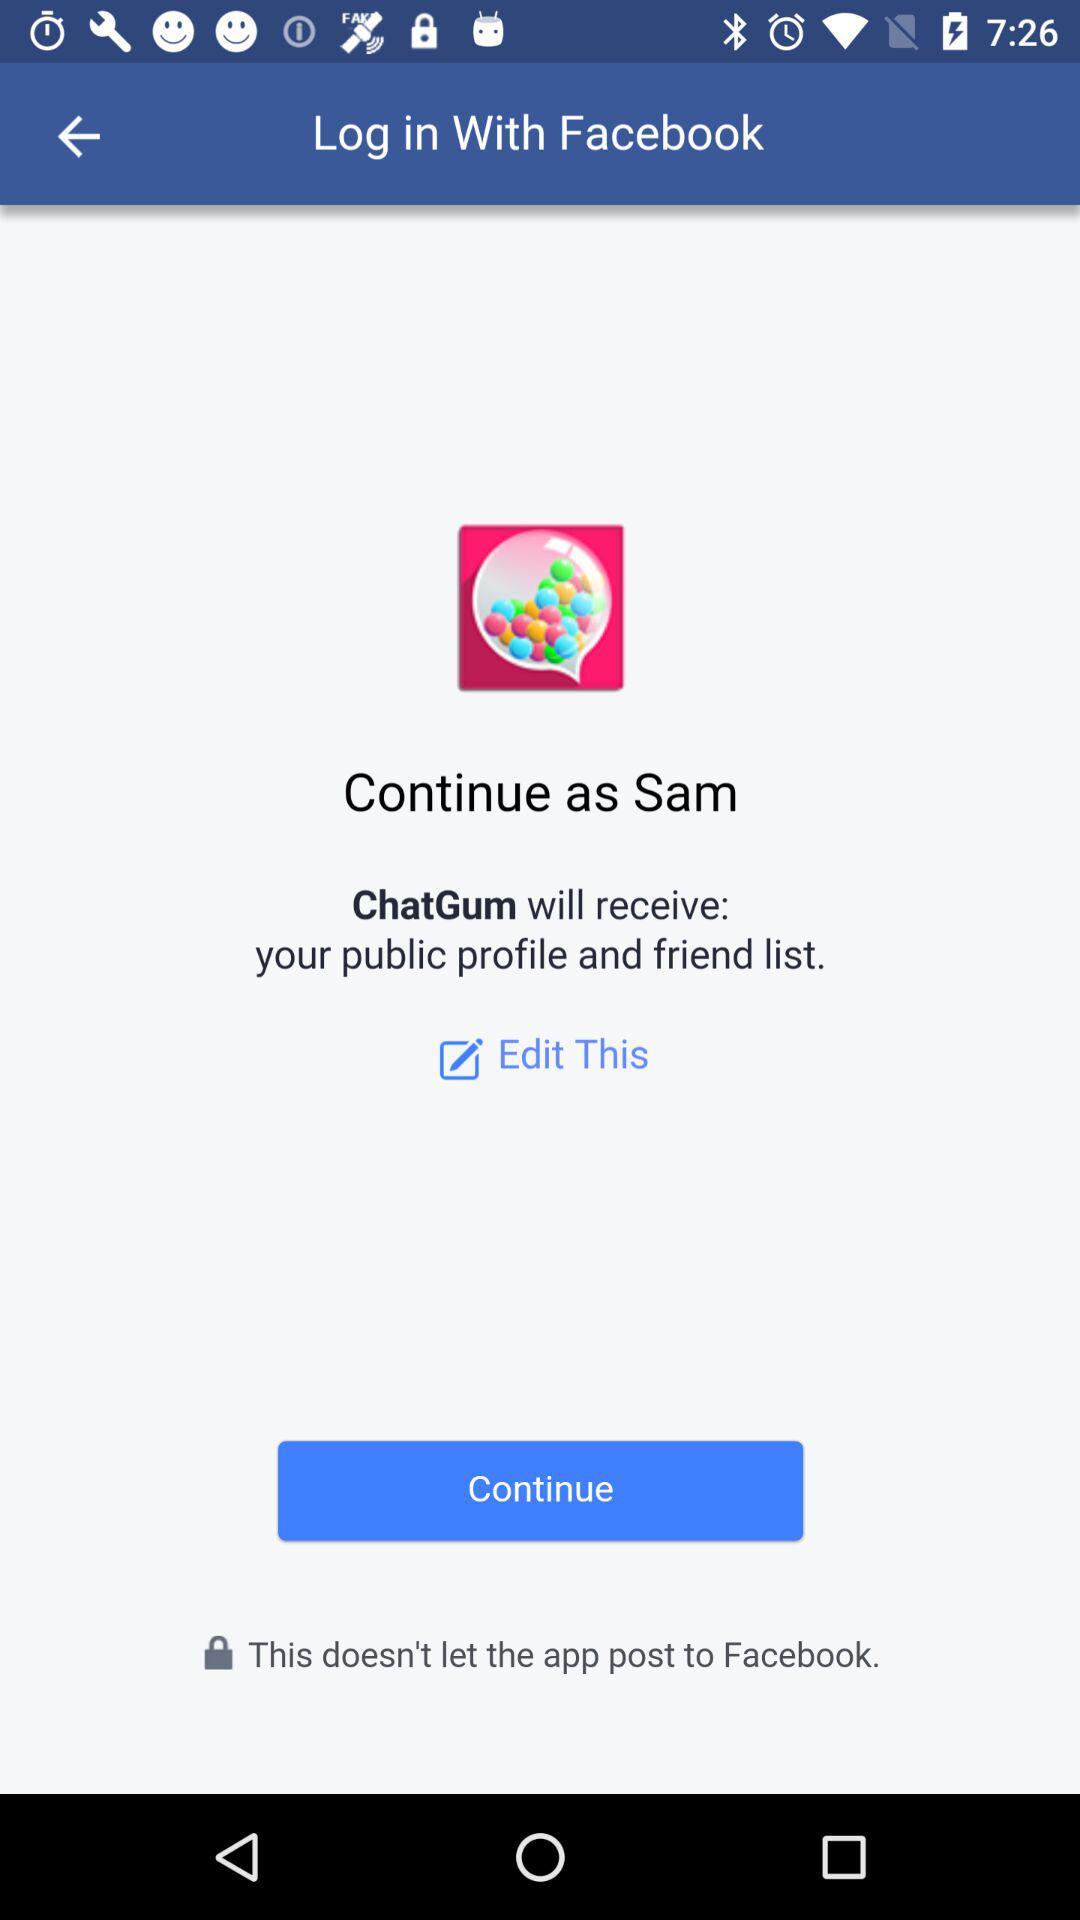What is the user's last name?
When the provided information is insufficient, respond with <no answer>. <no answer> 